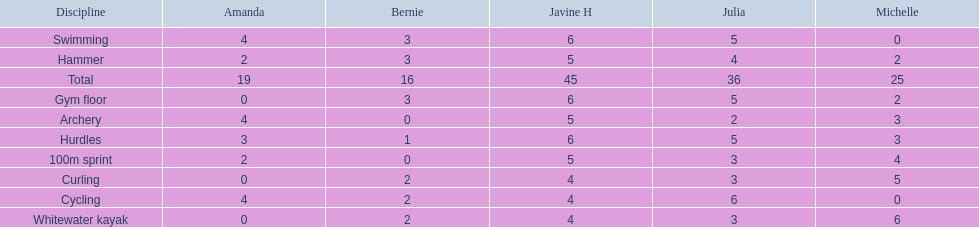Who scored the least on whitewater kayak? Amanda. 